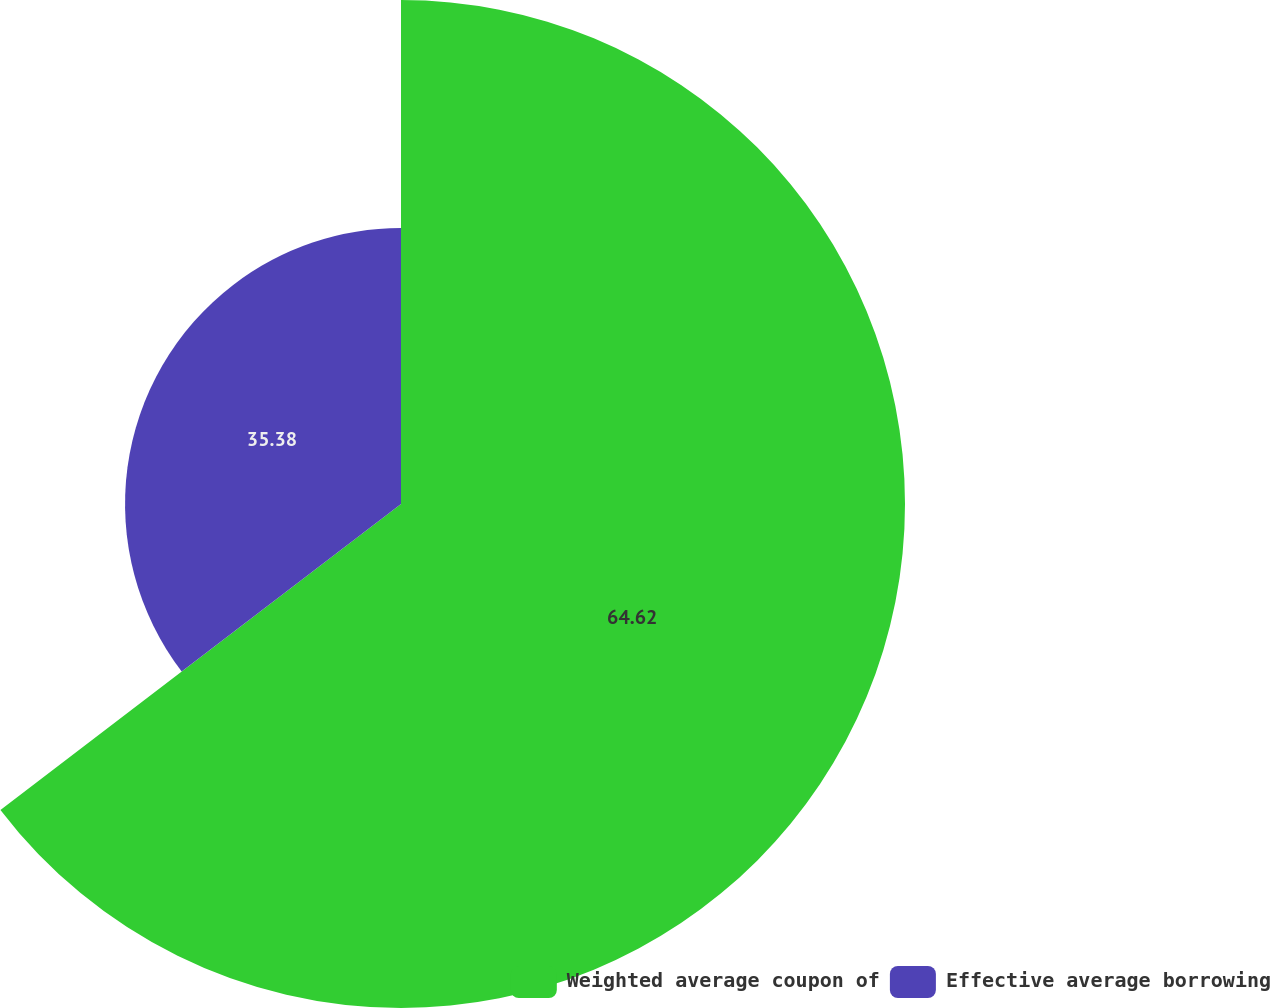Convert chart to OTSL. <chart><loc_0><loc_0><loc_500><loc_500><pie_chart><fcel>Weighted average coupon of<fcel>Effective average borrowing<nl><fcel>64.62%<fcel>35.38%<nl></chart> 